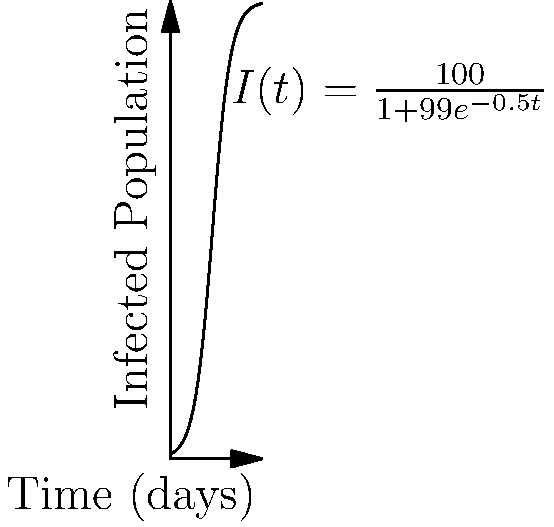In our healthcare facility, we're modeling the spread of a new infectious disease using a logistic growth model. The equation $I(t) = \frac{100}{1+99e^{-0.5t}}$ represents the number of infected individuals $I$ at time $t$ in days. What is the rate of change of infected individuals at day 10? To find the rate of change of infected individuals at day 10, we need to differentiate $I(t)$ and evaluate it at $t=10$. Let's approach this step-by-step:

1) First, let's differentiate $I(t)$ using the quotient rule:

   $\frac{dI}{dt} = \frac{(1+99e^{-0.5t}) \cdot 0 - 100 \cdot (-99 \cdot -0.5e^{-0.5t})}{(1+99e^{-0.5t})^2}$

2) Simplify:

   $\frac{dI}{dt} = \frac{100 \cdot 99 \cdot 0.5e^{-0.5t}}{(1+99e^{-0.5t})^2}$

3) Further simplify:

   $\frac{dI}{dt} = \frac{4950e^{-0.5t}}{(1+99e^{-0.5t})^2}$

4) Now, let's evaluate this at $t=10$:

   $\frac{dI}{dt}|_{t=10} = \frac{4950e^{-5}}{(1+99e^{-5})^2}$

5) Calculate the numerator and denominator separately:
   
   Numerator: $4950e^{-5} \approx 33.69$
   Denominator: $(1+99e^{-5})^2 \approx (1+0.67)^2 \approx 2.78$

6) Divide:

   $\frac{dI}{dt}|_{t=10} \approx \frac{33.69}{2.78} \approx 12.12$

Therefore, the rate of change of infected individuals at day 10 is approximately 12.12 individuals per day.
Answer: 12.12 individuals/day 